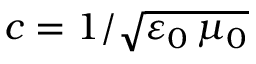<formula> <loc_0><loc_0><loc_500><loc_500>c = 1 / \sqrt { \varepsilon _ { 0 } \, \mu _ { 0 } }</formula> 